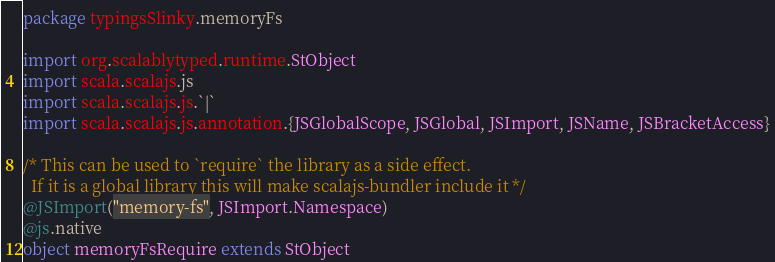<code> <loc_0><loc_0><loc_500><loc_500><_Scala_>package typingsSlinky.memoryFs

import org.scalablytyped.runtime.StObject
import scala.scalajs.js
import scala.scalajs.js.`|`
import scala.scalajs.js.annotation.{JSGlobalScope, JSGlobal, JSImport, JSName, JSBracketAccess}

/* This can be used to `require` the library as a side effect.
  If it is a global library this will make scalajs-bundler include it */
@JSImport("memory-fs", JSImport.Namespace)
@js.native
object memoryFsRequire extends StObject
</code> 